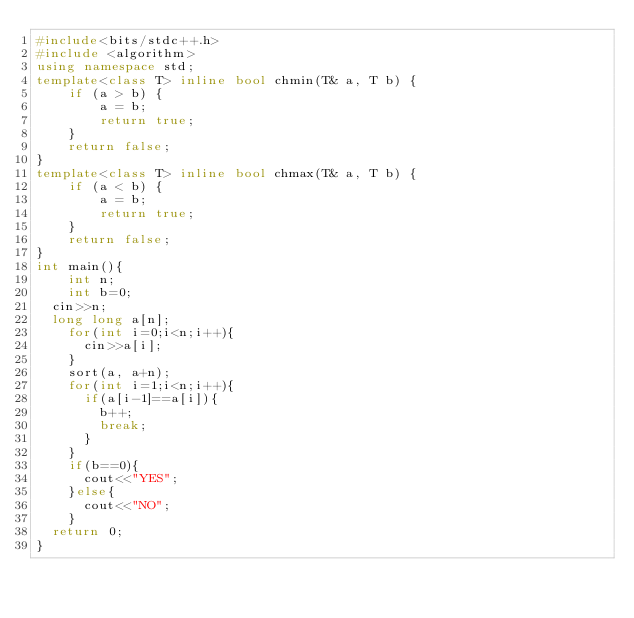Convert code to text. <code><loc_0><loc_0><loc_500><loc_500><_C++_>#include<bits/stdc++.h>
#include <algorithm>
using namespace std;
template<class T> inline bool chmin(T& a, T b) {
    if (a > b) {
        a = b;
        return true;
    }
    return false;
}
template<class T> inline bool chmax(T& a, T b) {
    if (a < b) {
        a = b;
        return true;
    }
    return false;
}
int main(){
    int n;
    int b=0;
	cin>>n;
	long long a[n];
    for(int i=0;i<n;i++){
      cin>>a[i];
    }
    sort(a, a+n);
    for(int i=1;i<n;i++){
      if(a[i-1]==a[i]){
        b++;
        break;
      }
    }
    if(b==0){
      cout<<"YES";
    }else{
      cout<<"NO";
    }
	return 0;
}</code> 